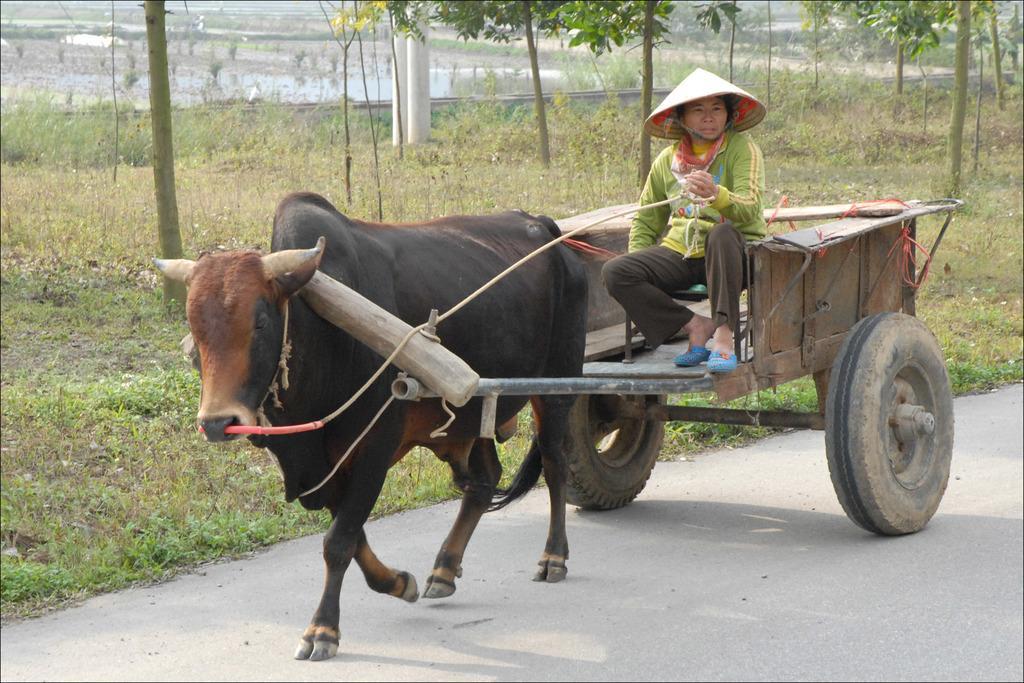How would you summarize this image in a sentence or two? In the foreground of this picture, there is a bull cart moving on the road where a man is sitting on it. In the background, there are trees, poles and farming fields. 